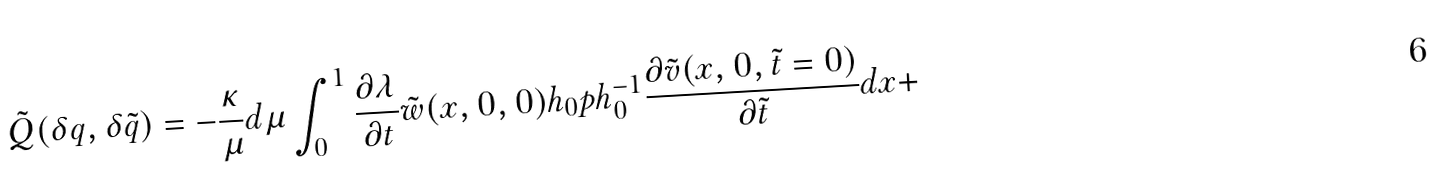Convert formula to latex. <formula><loc_0><loc_0><loc_500><loc_500>\tilde { Q } ( \delta q , \delta \tilde { q } ) = - \frac { \kappa } { \mu } d \mu \int _ { 0 } ^ { 1 } \frac { \partial \lambda } { \partial t } \tilde { w } ( x , 0 , 0 ) h _ { 0 } p h _ { 0 } ^ { - 1 } \frac { \partial \tilde { v } ( x , 0 , \tilde { t } = 0 ) } { \partial \tilde { t } } d x +</formula> 